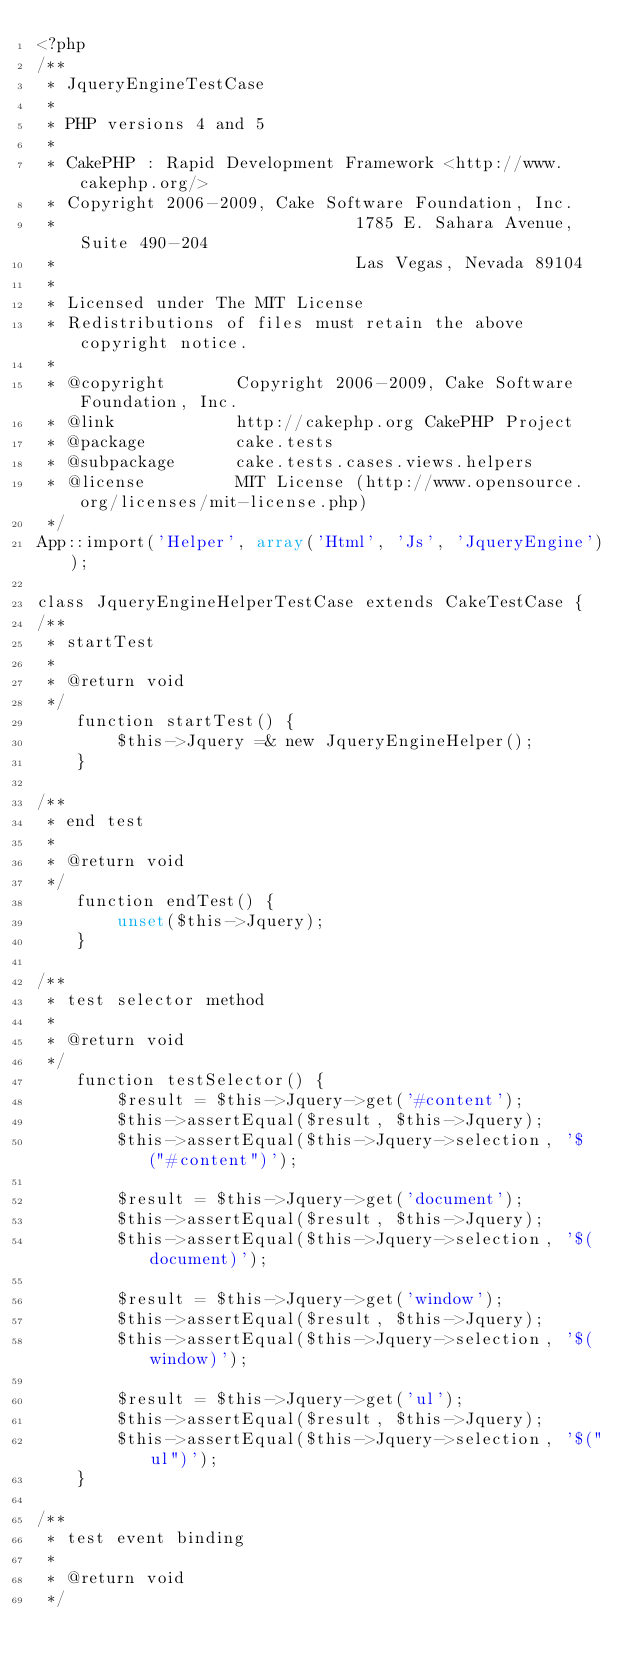<code> <loc_0><loc_0><loc_500><loc_500><_PHP_><?php
/**
 * JqueryEngineTestCase
 *
 * PHP versions 4 and 5
 *
 * CakePHP : Rapid Development Framework <http://www.cakephp.org/>
 * Copyright 2006-2009, Cake Software Foundation, Inc.
 *								1785 E. Sahara Avenue, Suite 490-204
 *								Las Vegas, Nevada 89104
 *
 * Licensed under The MIT License
 * Redistributions of files must retain the above copyright notice.
 *
 * @copyright       Copyright 2006-2009, Cake Software Foundation, Inc.
 * @link            http://cakephp.org CakePHP Project
 * @package         cake.tests
 * @subpackage      cake.tests.cases.views.helpers
 * @license         MIT License (http://www.opensource.org/licenses/mit-license.php)
 */
App::import('Helper', array('Html', 'Js', 'JqueryEngine'));

class JqueryEngineHelperTestCase extends CakeTestCase {
/**
 * startTest
 *
 * @return void
 */
	function startTest() {
		$this->Jquery =& new JqueryEngineHelper();
	}

/**
 * end test
 *
 * @return void
 */
	function endTest() {
		unset($this->Jquery);
	}

/**
 * test selector method
 *
 * @return void
 */
	function testSelector() {
		$result = $this->Jquery->get('#content');
		$this->assertEqual($result, $this->Jquery);
		$this->assertEqual($this->Jquery->selection, '$("#content")');

		$result = $this->Jquery->get('document');
		$this->assertEqual($result, $this->Jquery);
		$this->assertEqual($this->Jquery->selection, '$(document)');

		$result = $this->Jquery->get('window');
		$this->assertEqual($result, $this->Jquery);
		$this->assertEqual($this->Jquery->selection, '$(window)');

		$result = $this->Jquery->get('ul');
		$this->assertEqual($result, $this->Jquery);
		$this->assertEqual($this->Jquery->selection, '$("ul")');
	}

/**
 * test event binding
 *
 * @return void
 */</code> 